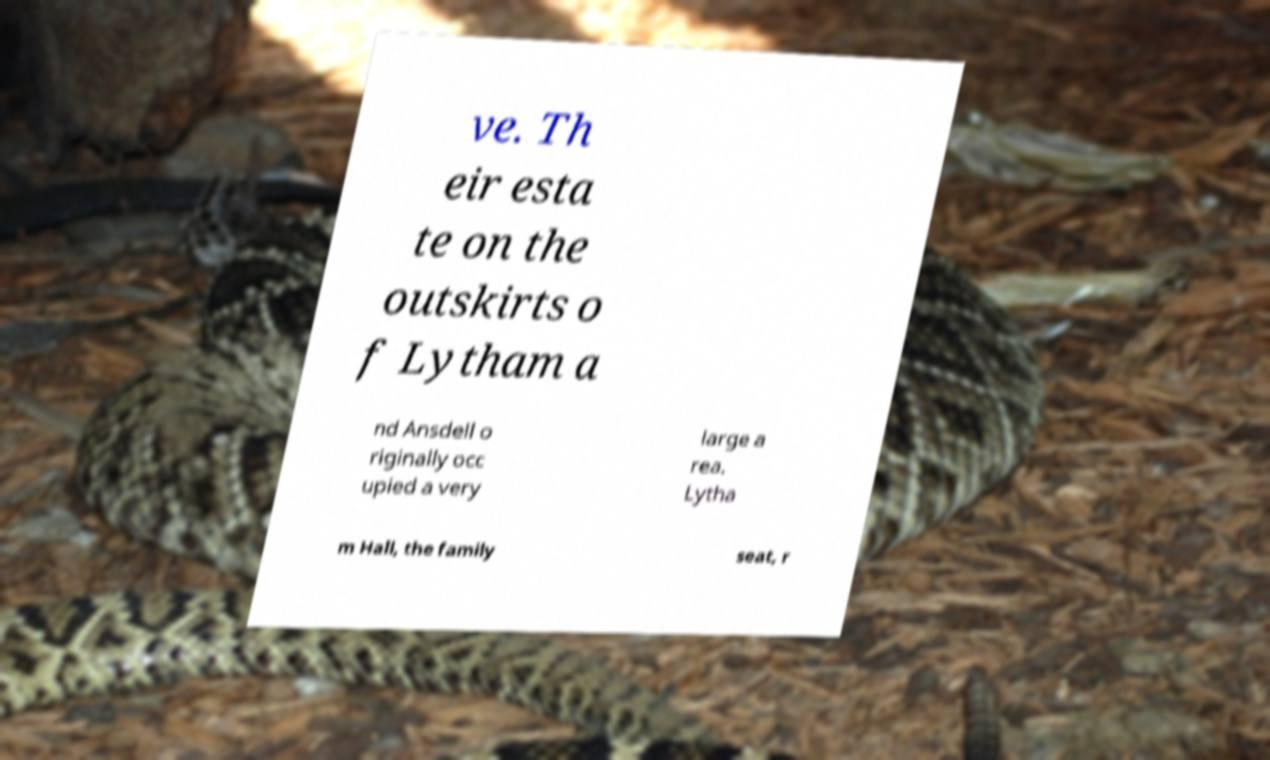Could you extract and type out the text from this image? ve. Th eir esta te on the outskirts o f Lytham a nd Ansdell o riginally occ upied a very large a rea. Lytha m Hall, the family seat, r 